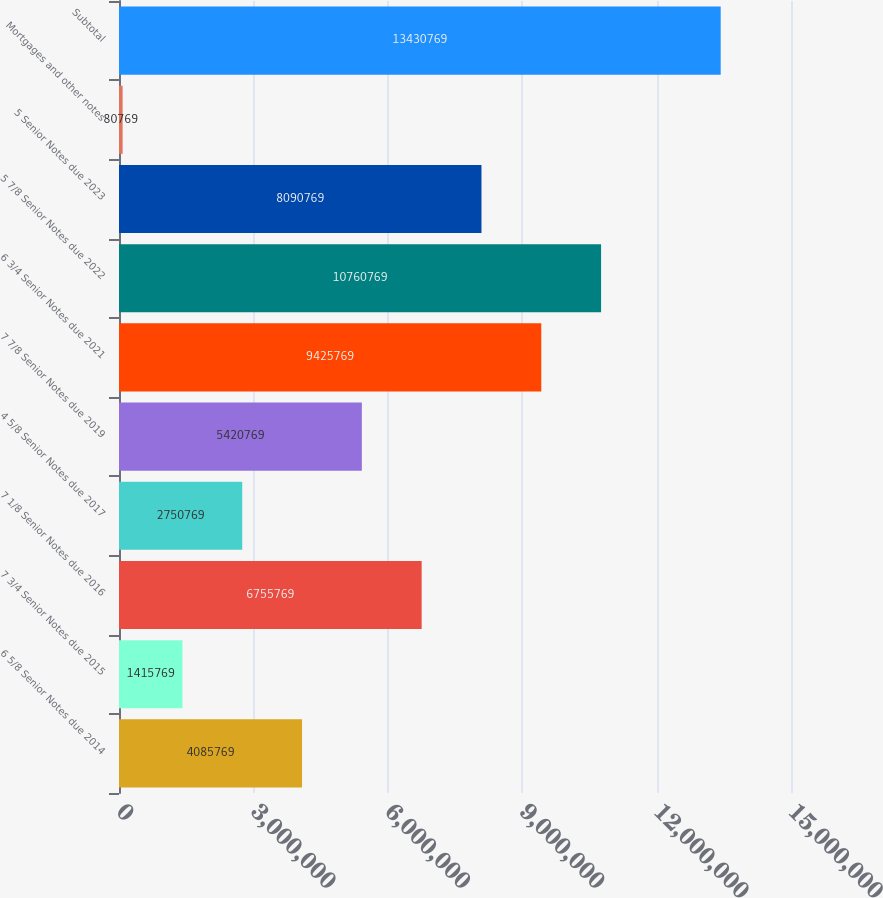<chart> <loc_0><loc_0><loc_500><loc_500><bar_chart><fcel>6 5/8 Senior Notes due 2014<fcel>7 3/4 Senior Notes due 2015<fcel>7 1/8 Senior Notes due 2016<fcel>4 5/8 Senior Notes due 2017<fcel>7 7/8 Senior Notes due 2019<fcel>6 3/4 Senior Notes due 2021<fcel>5 7/8 Senior Notes due 2022<fcel>5 Senior Notes due 2023<fcel>Mortgages and other notes<fcel>Subtotal<nl><fcel>4.08577e+06<fcel>1.41577e+06<fcel>6.75577e+06<fcel>2.75077e+06<fcel>5.42077e+06<fcel>9.42577e+06<fcel>1.07608e+07<fcel>8.09077e+06<fcel>80769<fcel>1.34308e+07<nl></chart> 